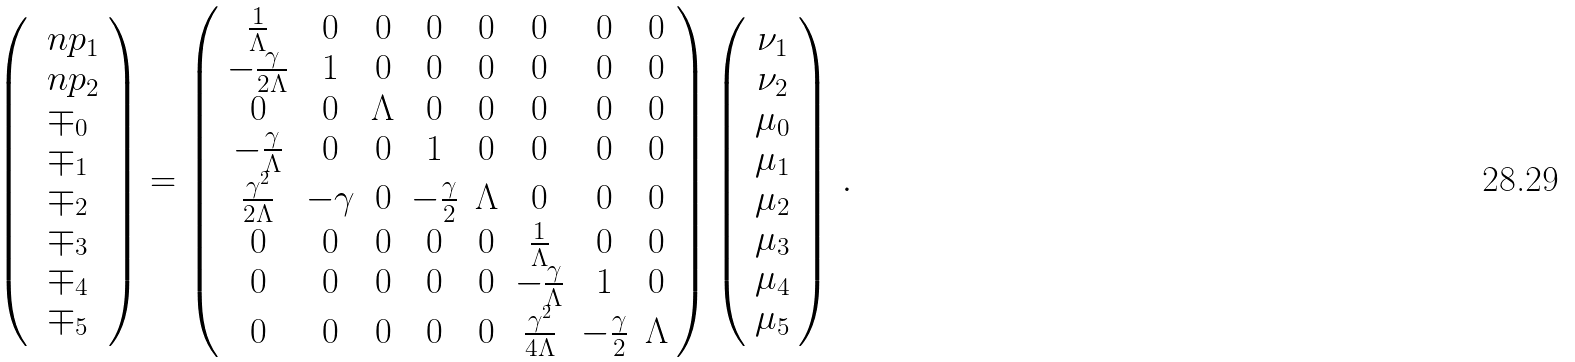Convert formula to latex. <formula><loc_0><loc_0><loc_500><loc_500>\left ( \begin{array} { c } \ n p _ { 1 } \\ \ n p _ { 2 } \\ \mp _ { 0 } \\ \mp _ { 1 } \\ \mp _ { 2 } \\ \mp _ { 3 } \\ \mp _ { 4 } \\ \mp _ { 5 } \end{array} \right ) = \left ( \begin{array} { c c c c c c c c } \frac { 1 } { \Lambda } & 0 & 0 & 0 & 0 & 0 & 0 & 0 \\ - \frac { \gamma } { 2 \Lambda } & 1 & 0 & 0 & 0 & 0 & 0 & 0 \\ 0 & 0 & \Lambda & 0 & 0 & 0 & 0 & 0 \\ - \frac { \gamma } { \Lambda } & 0 & 0 & 1 & 0 & 0 & 0 & 0 \\ \frac { \gamma ^ { 2 } } { 2 \Lambda } & - \gamma & 0 & - \frac { \gamma } { 2 } & \Lambda & 0 & 0 & 0 \\ 0 & 0 & 0 & 0 & 0 & \frac { 1 } { \Lambda } & 0 & 0 \\ 0 & 0 & 0 & 0 & 0 & - \frac { \gamma } { \Lambda } & 1 & 0 \\ 0 & 0 & 0 & 0 & 0 & \frac { \gamma ^ { 2 } } { 4 \Lambda } & - \frac { \gamma } { 2 } & \Lambda \end{array} \right ) \left ( \begin{array} { c } \nu _ { 1 } \\ \nu _ { 2 } \\ \mu _ { 0 } \\ \mu _ { 1 } \\ \mu _ { 2 } \\ \mu _ { 3 } \\ \mu _ { 4 } \\ \mu _ { 5 } \end{array} \right ) \, .</formula> 